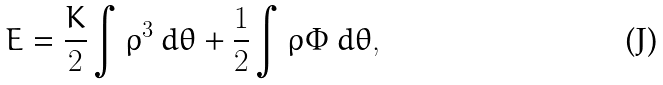Convert formula to latex. <formula><loc_0><loc_0><loc_500><loc_500>E = \frac { K } { 2 } \int \rho ^ { 3 } \, d \theta + \frac { 1 } { 2 } \int \rho \Phi \, d \theta ,</formula> 